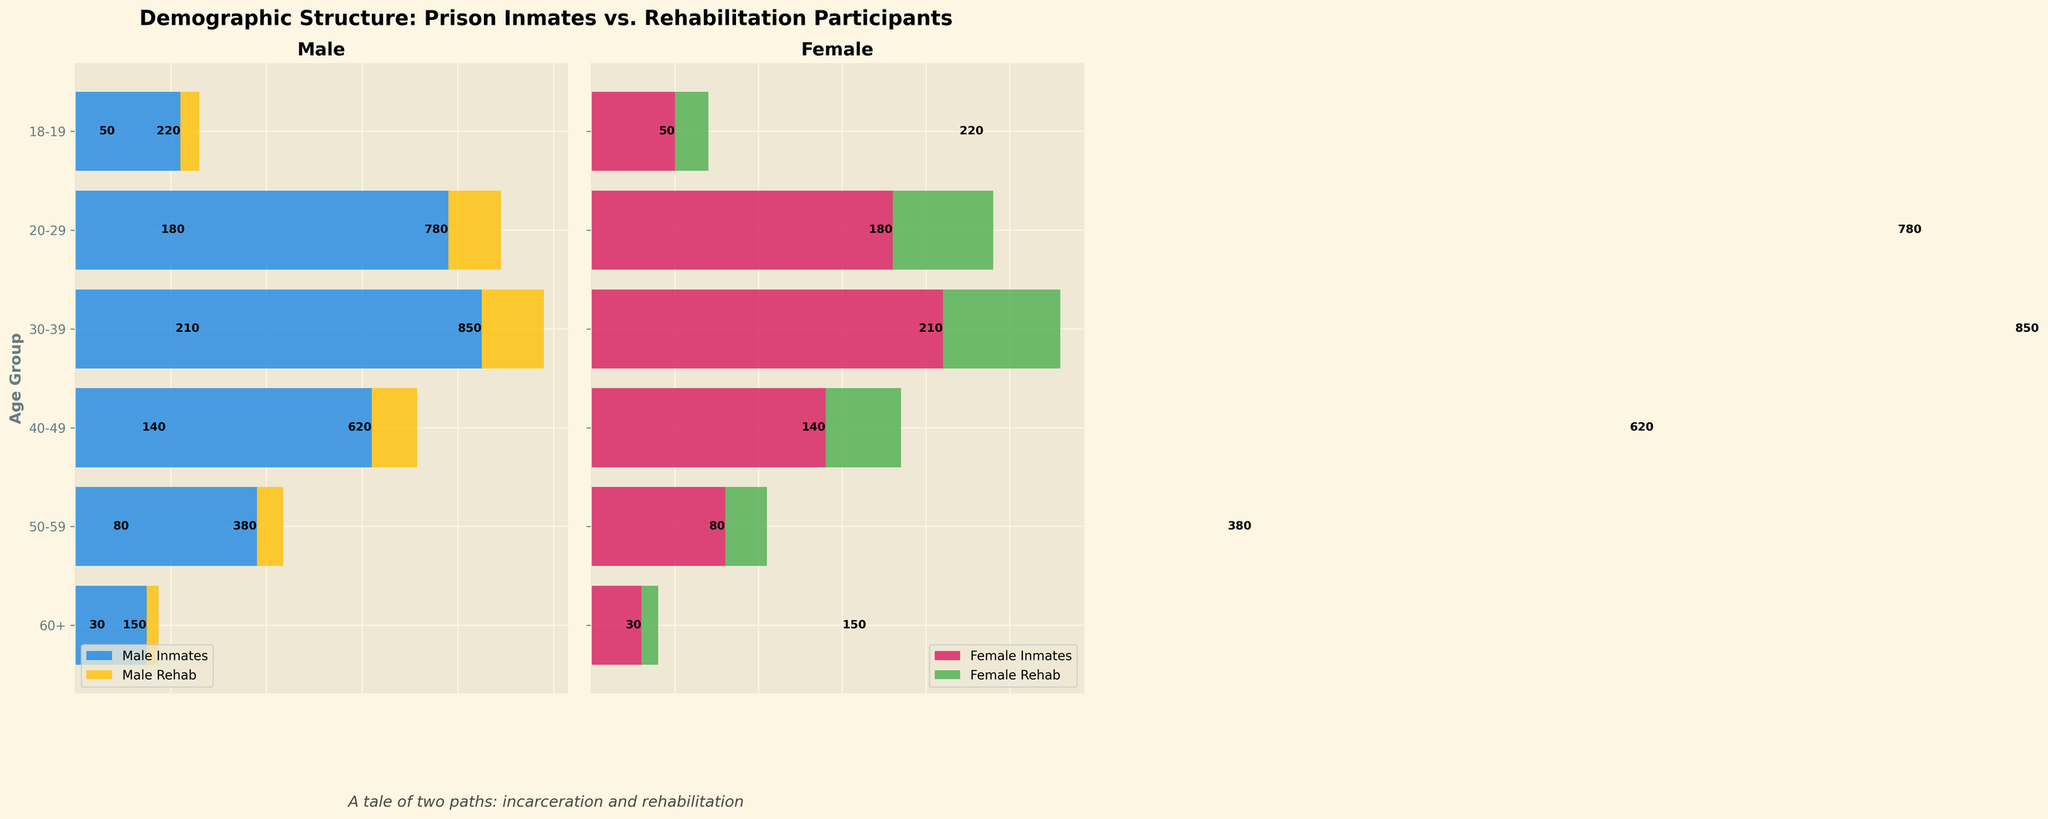what's the title of the figure? The title of the figure is directly stated at the top of the plot. It reads "Demographic Structure: Prison Inmates vs. Rehabilitation Participants".
Answer: Demographic Structure: Prison Inmates vs. Rehabilitation Participants Which age group has the smallest number of male inmates? By examining the horizontal bars on the left side of the figure under the "Male" section, the smallest bar corresponds to the "60+" age group which has the shortest bar.
Answer: 60+ What's the total number of female inmates in the 30-39 age group? Add the length of the bar for female inmates in the "30-39" age group, which is 210.
Answer: 210 How does the number of male inmates in the 40-49 age group compare to the number of male rehab participants in the same age group? The number of male inmates in the 40-49 age group is 620. The number of male rehab participants is 95. Comparing the two values, 620 is significantly greater than 95.
Answer: Greater Which age group has the highest number of female rehab participants? By looking at the right side of the figure, under the "Female" section, the bar for "30-39" age group reaches furthest to the right for female rehab participants.
Answer: 30-39 How many more male inmates are there compared to female inmates in the 20-29 age group? The number of male inmates is 780 and the number of female inmates is 180 in the 20-29 age group. The difference is 780 - 180, which equals 600.
Answer: 600 What's the combined number of male rehab participants across all age groups? Sum the numbers of male rehab participants across all age groups: 25 + 55 + 95 + 130 + 110 + 40 = 455.
Answer: 455 In which age group is the difference between male and female rehab participants the largest? Subtract the number of female rehab participants from male rehab participants in each age group: 60+ (25-10=15), 50-59 (55-25=30), 40-49 (95-45=50), 30-39 (130-70=60), 20-29 (110-60=50), 18-19 (40-20=20). The largest difference is in the 30-39 age group with 60.
Answer: 30-39 